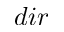Convert formula to latex. <formula><loc_0><loc_0><loc_500><loc_500>{ d i r }</formula> 